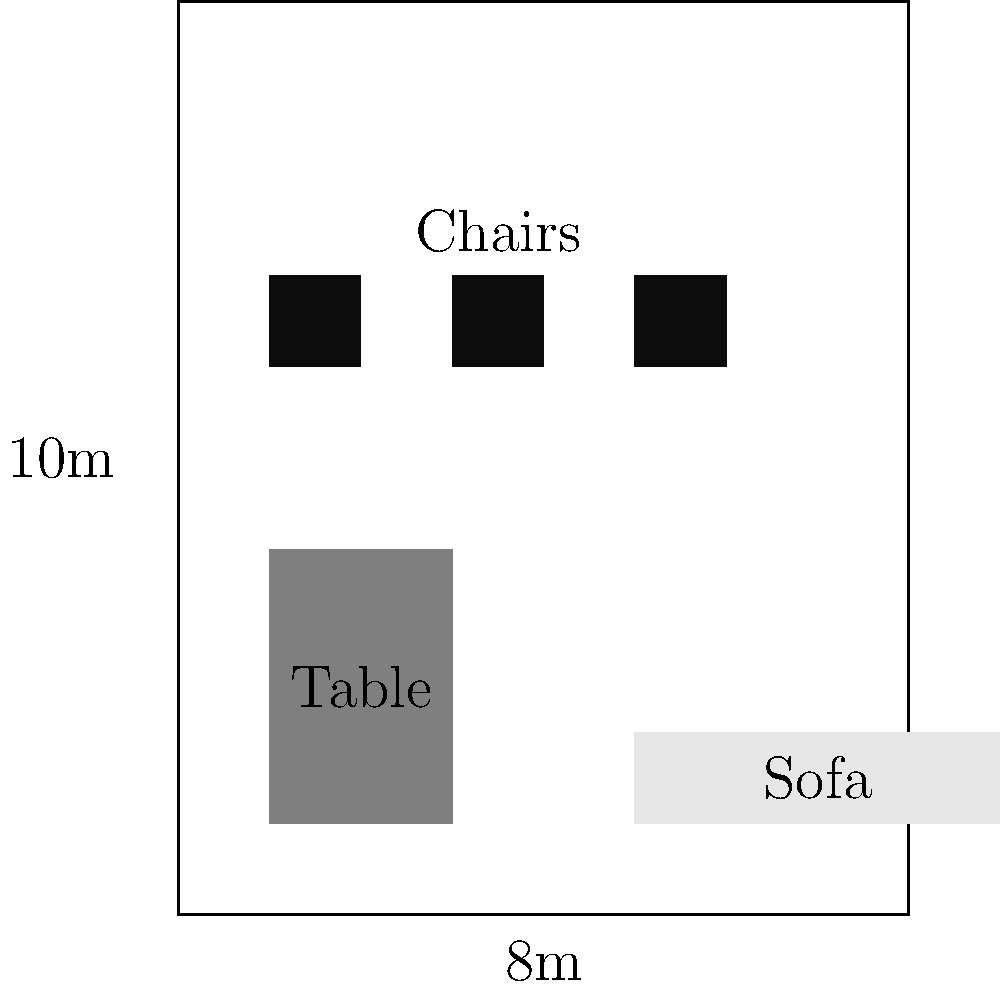As a furniture manufacturer, you're tasked with optimizing the arrangement of furniture in a rectangular room measuring 8m by 10m. The room contains a table (2m x 3m), a sofa (1m x 4m), and three chairs (each 1m x 1m). What is the maximum remaining floor area (in square meters) that can be achieved with an efficient arrangement of these furniture pieces? To solve this problem, we'll follow these steps:

1. Calculate the total area of the room:
   Room area = $8m \times 10m = 80m^2$

2. Calculate the area occupied by each furniture piece:
   - Table area = $2m \times 3m = 6m^2$
   - Sofa area = $1m \times 4m = 4m^2$
   - Chair area (each) = $1m \times 1m = 1m^2$
   - Total chair area = $3 \times 1m^2 = 3m^2$

3. Sum up the total area occupied by furniture:
   Total furniture area = Table + Sofa + Chairs
   $= 6m^2 + 4m^2 + 3m^2 = 13m^2$

4. Calculate the remaining floor area:
   Remaining area = Room area - Total furniture area
   $= 80m^2 - 13m^2 = 67m^2$

The maximum remaining floor area is achieved when the furniture is arranged efficiently without any unnecessary gaps between pieces or along the walls. This arrangement ensures that the furniture occupies the minimum possible space, leaving the maximum remaining area for other uses.
Answer: $67m^2$ 